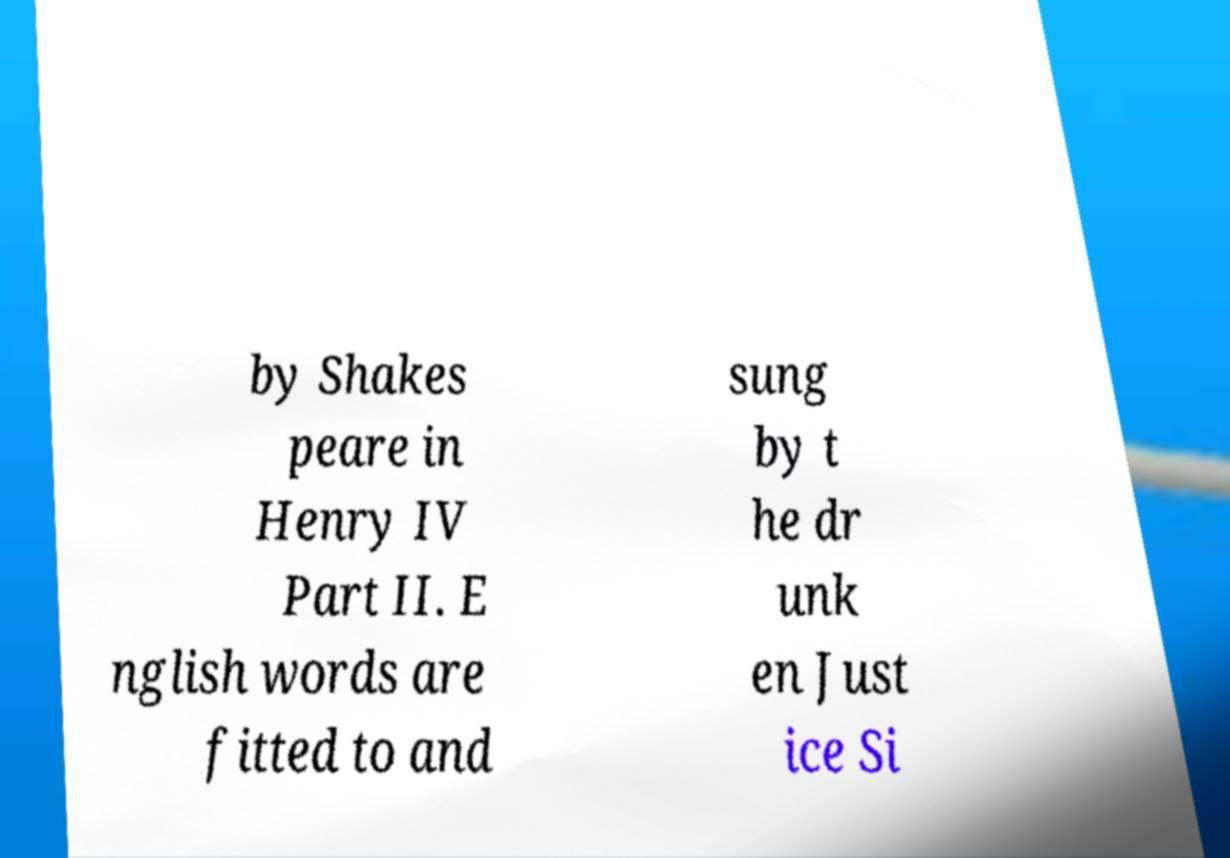Please identify and transcribe the text found in this image. by Shakes peare in Henry IV Part II. E nglish words are fitted to and sung by t he dr unk en Just ice Si 